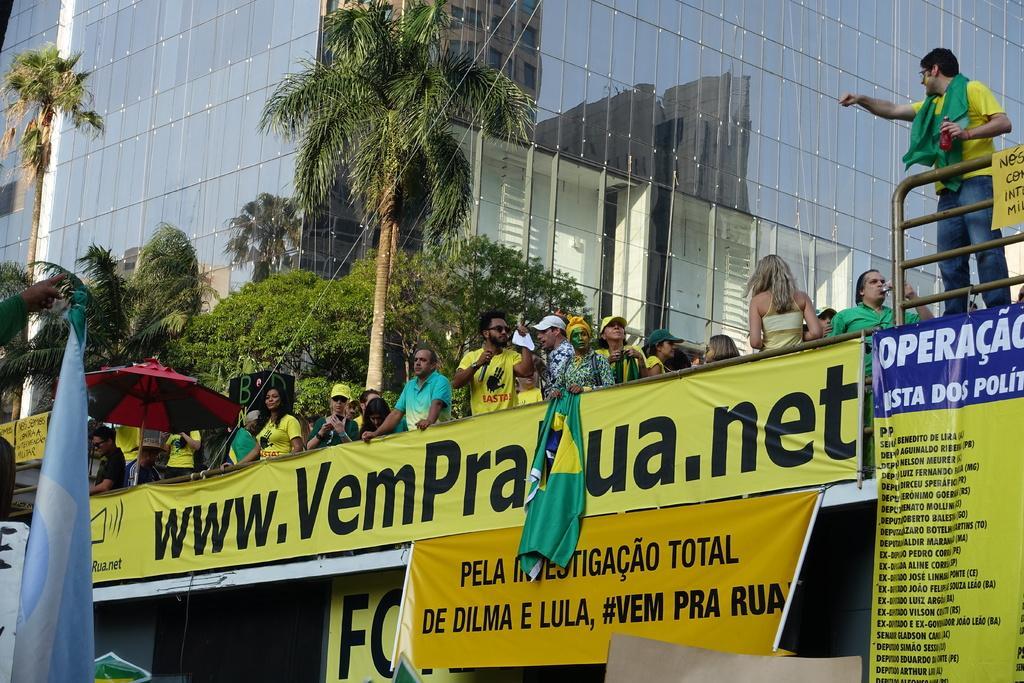How would you summarize this image in a sentence or two? In this image we can see one big glass building, so many banners with some text, some boards, one tent, some people standing, some trees, some flags, some different objects are on the surface and some people are holding some objects. 